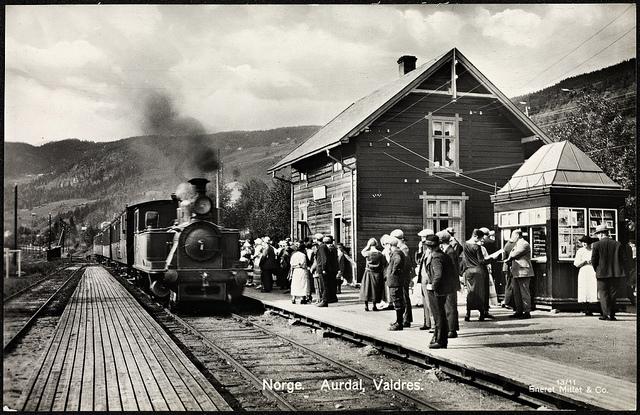How many people in the photo?
Answer briefly. 20. What color is the picture?
Be succinct. Black and white. How many windows in the building?
Short answer required. 4. How many people are waiting for the train?
Give a very brief answer. 25. What mode of transportation is this?
Give a very brief answer. Train. 